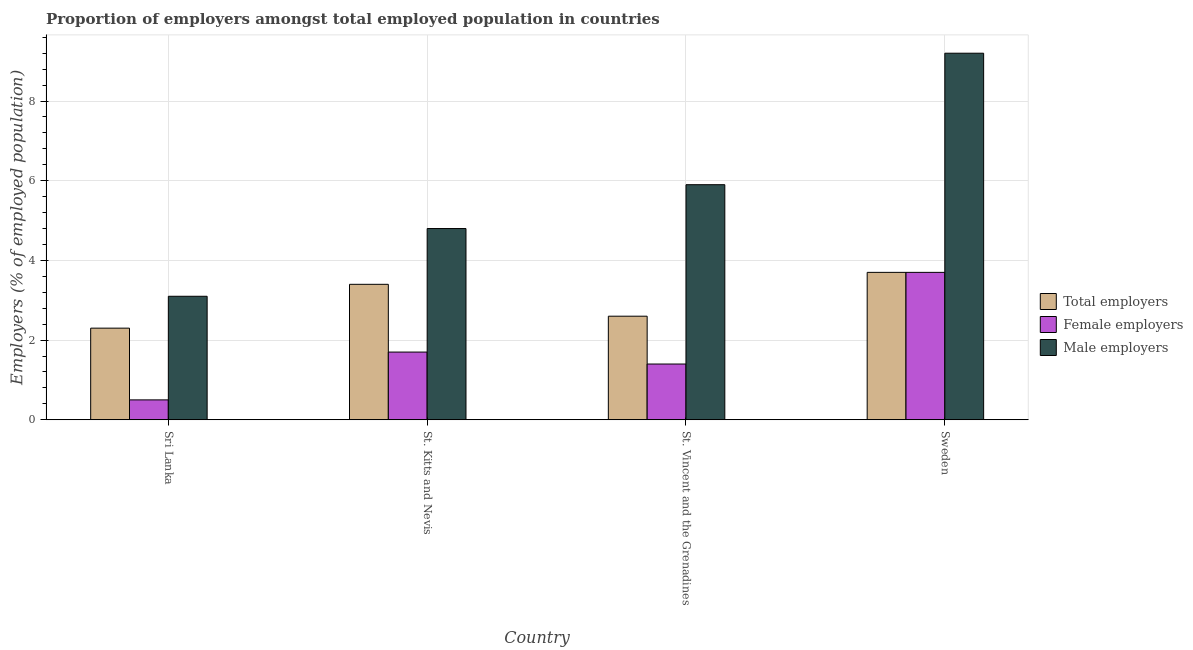How many bars are there on the 4th tick from the left?
Make the answer very short. 3. What is the label of the 2nd group of bars from the left?
Offer a very short reply. St. Kitts and Nevis. In how many cases, is the number of bars for a given country not equal to the number of legend labels?
Offer a terse response. 0. Across all countries, what is the maximum percentage of male employers?
Offer a very short reply. 9.2. Across all countries, what is the minimum percentage of male employers?
Keep it short and to the point. 3.1. In which country was the percentage of female employers maximum?
Offer a very short reply. Sweden. In which country was the percentage of total employers minimum?
Your response must be concise. Sri Lanka. What is the total percentage of total employers in the graph?
Offer a terse response. 12. What is the difference between the percentage of total employers in Sri Lanka and that in St. Kitts and Nevis?
Keep it short and to the point. -1.1. What is the difference between the percentage of male employers in St. Vincent and the Grenadines and the percentage of female employers in Sweden?
Offer a very short reply. 2.2. What is the average percentage of male employers per country?
Your answer should be compact. 5.75. What is the difference between the percentage of male employers and percentage of female employers in St. Kitts and Nevis?
Provide a succinct answer. 3.1. What is the ratio of the percentage of male employers in Sri Lanka to that in St. Vincent and the Grenadines?
Make the answer very short. 0.53. Is the percentage of male employers in St. Vincent and the Grenadines less than that in Sweden?
Your response must be concise. Yes. Is the difference between the percentage of total employers in St. Kitts and Nevis and St. Vincent and the Grenadines greater than the difference between the percentage of female employers in St. Kitts and Nevis and St. Vincent and the Grenadines?
Give a very brief answer. Yes. What is the difference between the highest and the second highest percentage of female employers?
Offer a very short reply. 2. What is the difference between the highest and the lowest percentage of total employers?
Ensure brevity in your answer.  1.4. In how many countries, is the percentage of male employers greater than the average percentage of male employers taken over all countries?
Keep it short and to the point. 2. What does the 1st bar from the left in St. Kitts and Nevis represents?
Provide a short and direct response. Total employers. What does the 3rd bar from the right in St. Kitts and Nevis represents?
Your answer should be compact. Total employers. Is it the case that in every country, the sum of the percentage of total employers and percentage of female employers is greater than the percentage of male employers?
Keep it short and to the point. No. How many bars are there?
Offer a very short reply. 12. Are all the bars in the graph horizontal?
Give a very brief answer. No. How many countries are there in the graph?
Keep it short and to the point. 4. Does the graph contain any zero values?
Ensure brevity in your answer.  No. Does the graph contain grids?
Your answer should be very brief. Yes. Where does the legend appear in the graph?
Offer a very short reply. Center right. How many legend labels are there?
Keep it short and to the point. 3. What is the title of the graph?
Provide a short and direct response. Proportion of employers amongst total employed population in countries. Does "Other sectors" appear as one of the legend labels in the graph?
Ensure brevity in your answer.  No. What is the label or title of the X-axis?
Provide a short and direct response. Country. What is the label or title of the Y-axis?
Your answer should be very brief. Employers (% of employed population). What is the Employers (% of employed population) in Total employers in Sri Lanka?
Keep it short and to the point. 2.3. What is the Employers (% of employed population) of Male employers in Sri Lanka?
Give a very brief answer. 3.1. What is the Employers (% of employed population) of Total employers in St. Kitts and Nevis?
Ensure brevity in your answer.  3.4. What is the Employers (% of employed population) in Female employers in St. Kitts and Nevis?
Offer a very short reply. 1.7. What is the Employers (% of employed population) of Male employers in St. Kitts and Nevis?
Keep it short and to the point. 4.8. What is the Employers (% of employed population) in Total employers in St. Vincent and the Grenadines?
Give a very brief answer. 2.6. What is the Employers (% of employed population) in Female employers in St. Vincent and the Grenadines?
Offer a terse response. 1.4. What is the Employers (% of employed population) of Male employers in St. Vincent and the Grenadines?
Make the answer very short. 5.9. What is the Employers (% of employed population) of Total employers in Sweden?
Your answer should be very brief. 3.7. What is the Employers (% of employed population) of Female employers in Sweden?
Offer a terse response. 3.7. What is the Employers (% of employed population) in Male employers in Sweden?
Your answer should be very brief. 9.2. Across all countries, what is the maximum Employers (% of employed population) of Total employers?
Give a very brief answer. 3.7. Across all countries, what is the maximum Employers (% of employed population) in Female employers?
Ensure brevity in your answer.  3.7. Across all countries, what is the maximum Employers (% of employed population) of Male employers?
Your answer should be compact. 9.2. Across all countries, what is the minimum Employers (% of employed population) in Total employers?
Keep it short and to the point. 2.3. Across all countries, what is the minimum Employers (% of employed population) in Male employers?
Your response must be concise. 3.1. What is the total Employers (% of employed population) of Male employers in the graph?
Make the answer very short. 23. What is the difference between the Employers (% of employed population) of Total employers in Sri Lanka and that in St. Kitts and Nevis?
Give a very brief answer. -1.1. What is the difference between the Employers (% of employed population) in Female employers in Sri Lanka and that in St. Kitts and Nevis?
Your answer should be very brief. -1.2. What is the difference between the Employers (% of employed population) in Total employers in Sri Lanka and that in St. Vincent and the Grenadines?
Ensure brevity in your answer.  -0.3. What is the difference between the Employers (% of employed population) in Male employers in Sri Lanka and that in St. Vincent and the Grenadines?
Keep it short and to the point. -2.8. What is the difference between the Employers (% of employed population) in Female employers in Sri Lanka and that in Sweden?
Provide a short and direct response. -3.2. What is the difference between the Employers (% of employed population) in Male employers in Sri Lanka and that in Sweden?
Your response must be concise. -6.1. What is the difference between the Employers (% of employed population) in Female employers in St. Kitts and Nevis and that in St. Vincent and the Grenadines?
Provide a short and direct response. 0.3. What is the difference between the Employers (% of employed population) of Male employers in St. Kitts and Nevis and that in St. Vincent and the Grenadines?
Offer a very short reply. -1.1. What is the difference between the Employers (% of employed population) in Total employers in St. Kitts and Nevis and that in Sweden?
Your answer should be very brief. -0.3. What is the difference between the Employers (% of employed population) in Female employers in St. Kitts and Nevis and that in Sweden?
Offer a very short reply. -2. What is the difference between the Employers (% of employed population) in Total employers in St. Vincent and the Grenadines and that in Sweden?
Offer a very short reply. -1.1. What is the difference between the Employers (% of employed population) in Female employers in St. Vincent and the Grenadines and that in Sweden?
Your answer should be very brief. -2.3. What is the difference between the Employers (% of employed population) in Male employers in St. Vincent and the Grenadines and that in Sweden?
Your answer should be very brief. -3.3. What is the difference between the Employers (% of employed population) of Total employers in Sri Lanka and the Employers (% of employed population) of Female employers in St. Kitts and Nevis?
Offer a very short reply. 0.6. What is the difference between the Employers (% of employed population) in Female employers in Sri Lanka and the Employers (% of employed population) in Male employers in St. Kitts and Nevis?
Provide a succinct answer. -4.3. What is the difference between the Employers (% of employed population) of Total employers in Sri Lanka and the Employers (% of employed population) of Female employers in St. Vincent and the Grenadines?
Your answer should be very brief. 0.9. What is the difference between the Employers (% of employed population) of Total employers in Sri Lanka and the Employers (% of employed population) of Male employers in St. Vincent and the Grenadines?
Offer a very short reply. -3.6. What is the difference between the Employers (% of employed population) in Female employers in Sri Lanka and the Employers (% of employed population) in Male employers in St. Vincent and the Grenadines?
Provide a succinct answer. -5.4. What is the difference between the Employers (% of employed population) of Total employers in Sri Lanka and the Employers (% of employed population) of Female employers in Sweden?
Ensure brevity in your answer.  -1.4. What is the difference between the Employers (% of employed population) in Total employers in Sri Lanka and the Employers (% of employed population) in Male employers in Sweden?
Offer a terse response. -6.9. What is the difference between the Employers (% of employed population) of Total employers in St. Kitts and Nevis and the Employers (% of employed population) of Male employers in Sweden?
Provide a succinct answer. -5.8. What is the difference between the Employers (% of employed population) of Female employers in St. Kitts and Nevis and the Employers (% of employed population) of Male employers in Sweden?
Provide a short and direct response. -7.5. What is the difference between the Employers (% of employed population) of Total employers in St. Vincent and the Grenadines and the Employers (% of employed population) of Female employers in Sweden?
Offer a very short reply. -1.1. What is the difference between the Employers (% of employed population) in Female employers in St. Vincent and the Grenadines and the Employers (% of employed population) in Male employers in Sweden?
Offer a very short reply. -7.8. What is the average Employers (% of employed population) in Female employers per country?
Provide a short and direct response. 1.82. What is the average Employers (% of employed population) of Male employers per country?
Make the answer very short. 5.75. What is the difference between the Employers (% of employed population) in Total employers and Employers (% of employed population) in Male employers in Sri Lanka?
Your answer should be very brief. -0.8. What is the difference between the Employers (% of employed population) of Female employers and Employers (% of employed population) of Male employers in Sri Lanka?
Provide a succinct answer. -2.6. What is the difference between the Employers (% of employed population) in Female employers and Employers (% of employed population) in Male employers in St. Kitts and Nevis?
Give a very brief answer. -3.1. What is the difference between the Employers (% of employed population) of Female employers and Employers (% of employed population) of Male employers in St. Vincent and the Grenadines?
Provide a short and direct response. -4.5. What is the difference between the Employers (% of employed population) of Total employers and Employers (% of employed population) of Female employers in Sweden?
Keep it short and to the point. 0. What is the difference between the Employers (% of employed population) in Total employers and Employers (% of employed population) in Male employers in Sweden?
Your answer should be very brief. -5.5. What is the difference between the Employers (% of employed population) in Female employers and Employers (% of employed population) in Male employers in Sweden?
Provide a succinct answer. -5.5. What is the ratio of the Employers (% of employed population) in Total employers in Sri Lanka to that in St. Kitts and Nevis?
Your response must be concise. 0.68. What is the ratio of the Employers (% of employed population) in Female employers in Sri Lanka to that in St. Kitts and Nevis?
Provide a short and direct response. 0.29. What is the ratio of the Employers (% of employed population) of Male employers in Sri Lanka to that in St. Kitts and Nevis?
Provide a succinct answer. 0.65. What is the ratio of the Employers (% of employed population) of Total employers in Sri Lanka to that in St. Vincent and the Grenadines?
Your answer should be very brief. 0.88. What is the ratio of the Employers (% of employed population) in Female employers in Sri Lanka to that in St. Vincent and the Grenadines?
Provide a short and direct response. 0.36. What is the ratio of the Employers (% of employed population) in Male employers in Sri Lanka to that in St. Vincent and the Grenadines?
Your answer should be very brief. 0.53. What is the ratio of the Employers (% of employed population) of Total employers in Sri Lanka to that in Sweden?
Offer a very short reply. 0.62. What is the ratio of the Employers (% of employed population) in Female employers in Sri Lanka to that in Sweden?
Offer a very short reply. 0.14. What is the ratio of the Employers (% of employed population) of Male employers in Sri Lanka to that in Sweden?
Your answer should be compact. 0.34. What is the ratio of the Employers (% of employed population) in Total employers in St. Kitts and Nevis to that in St. Vincent and the Grenadines?
Make the answer very short. 1.31. What is the ratio of the Employers (% of employed population) of Female employers in St. Kitts and Nevis to that in St. Vincent and the Grenadines?
Offer a terse response. 1.21. What is the ratio of the Employers (% of employed population) in Male employers in St. Kitts and Nevis to that in St. Vincent and the Grenadines?
Your response must be concise. 0.81. What is the ratio of the Employers (% of employed population) of Total employers in St. Kitts and Nevis to that in Sweden?
Make the answer very short. 0.92. What is the ratio of the Employers (% of employed population) of Female employers in St. Kitts and Nevis to that in Sweden?
Your response must be concise. 0.46. What is the ratio of the Employers (% of employed population) in Male employers in St. Kitts and Nevis to that in Sweden?
Keep it short and to the point. 0.52. What is the ratio of the Employers (% of employed population) of Total employers in St. Vincent and the Grenadines to that in Sweden?
Your answer should be compact. 0.7. What is the ratio of the Employers (% of employed population) of Female employers in St. Vincent and the Grenadines to that in Sweden?
Keep it short and to the point. 0.38. What is the ratio of the Employers (% of employed population) of Male employers in St. Vincent and the Grenadines to that in Sweden?
Keep it short and to the point. 0.64. What is the difference between the highest and the second highest Employers (% of employed population) in Female employers?
Give a very brief answer. 2. What is the difference between the highest and the second highest Employers (% of employed population) of Male employers?
Offer a very short reply. 3.3. What is the difference between the highest and the lowest Employers (% of employed population) of Female employers?
Give a very brief answer. 3.2. What is the difference between the highest and the lowest Employers (% of employed population) of Male employers?
Offer a very short reply. 6.1. 